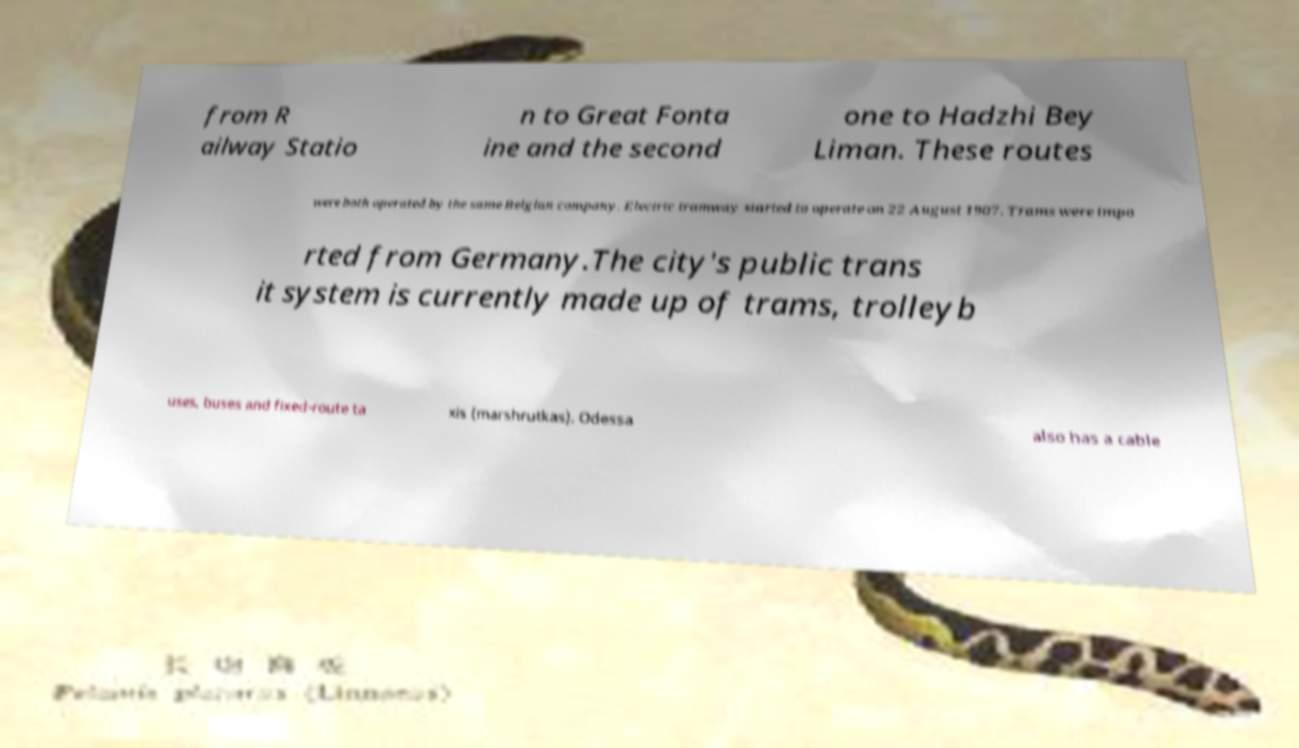There's text embedded in this image that I need extracted. Can you transcribe it verbatim? from R ailway Statio n to Great Fonta ine and the second one to Hadzhi Bey Liman. These routes were both operated by the same Belgian company. Electric tramway started to operate on 22 August 1907. Trams were impo rted from Germany.The city's public trans it system is currently made up of trams, trolleyb uses, buses and fixed-route ta xis (marshrutkas). Odessa also has a cable 